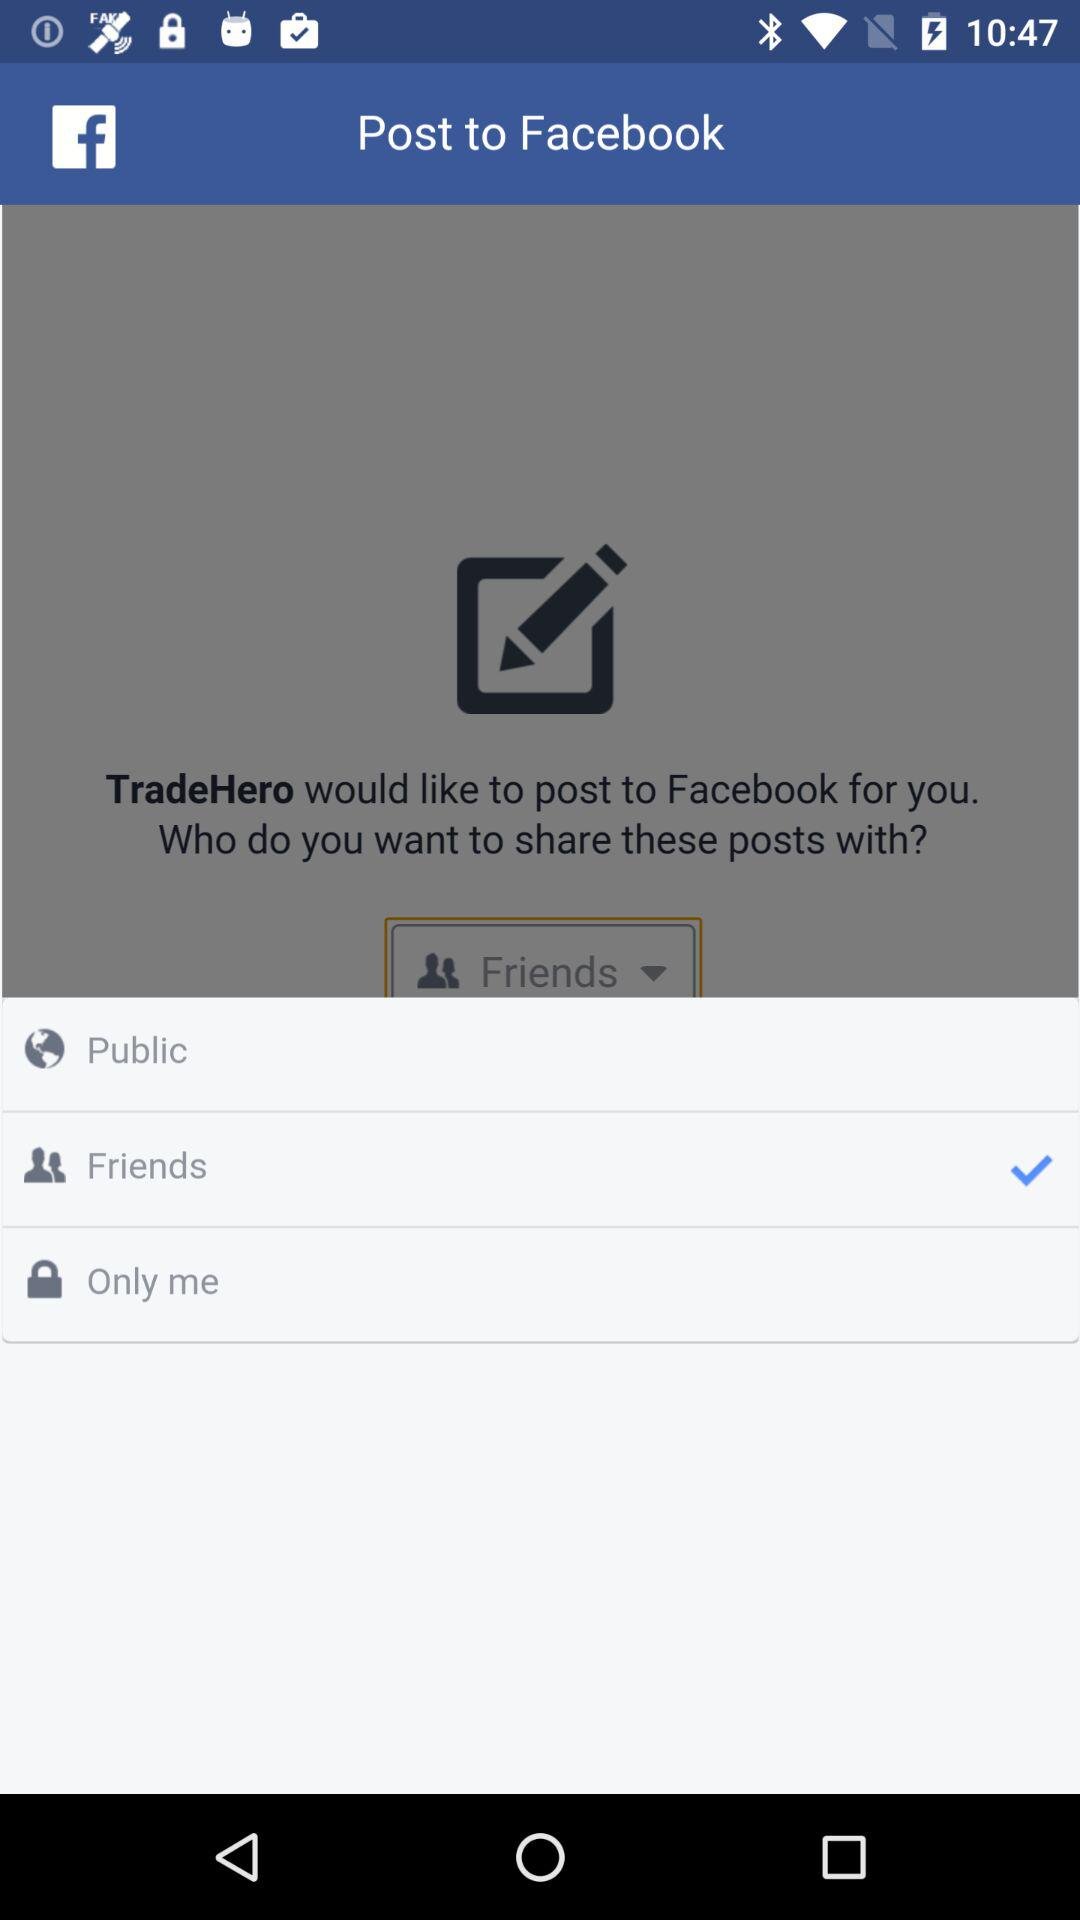Which option has been selected for the facebook post? The selected option is "Friends". 